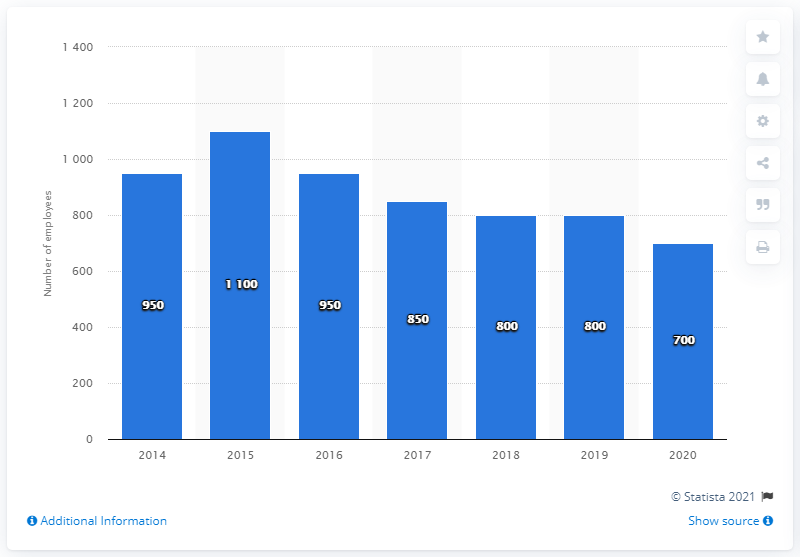Highlight a few significant elements in this photo. As of 2020, Bloomin' Brands had approximately 800 employees. 